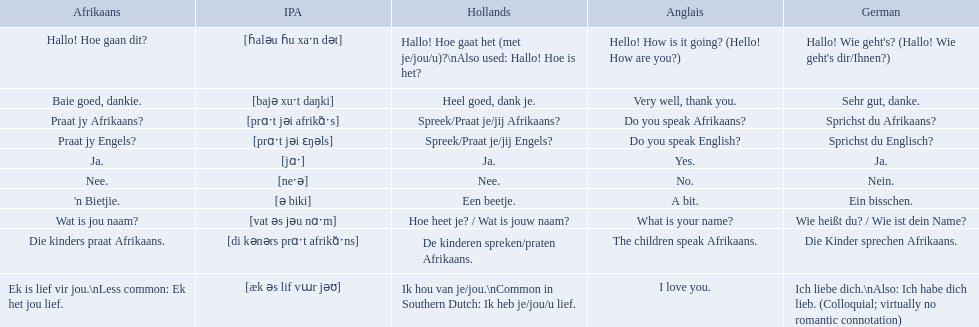Can you give me this table in json format? {'header': ['Afrikaans', 'IPA', 'Hollands', 'Anglais', 'German'], 'rows': [['Hallo! Hoe gaan dit?', '[ɦaləu ɦu xaˑn dət]', 'Hallo! Hoe gaat het (met je/jou/u)?\\nAlso used: Hallo! Hoe is het?', 'Hello! How is it going? (Hello! How are you?)', "Hallo! Wie geht's? (Hallo! Wie geht's dir/Ihnen?)"], ['Baie goed, dankie.', '[bajə xuˑt daŋki]', 'Heel goed, dank je.', 'Very well, thank you.', 'Sehr gut, danke.'], ['Praat jy Afrikaans?', '[prɑˑt jəi afrikɑ̃ˑs]', 'Spreek/Praat je/jij Afrikaans?', 'Do you speak Afrikaans?', 'Sprichst du Afrikaans?'], ['Praat jy Engels?', '[prɑˑt jəi ɛŋəls]', 'Spreek/Praat je/jij Engels?', 'Do you speak English?', 'Sprichst du Englisch?'], ['Ja.', '[jɑˑ]', 'Ja.', 'Yes.', 'Ja.'], ['Nee.', '[neˑə]', 'Nee.', 'No.', 'Nein.'], ["'n Bietjie.", '[ə biki]', 'Een beetje.', 'A bit.', 'Ein bisschen.'], ['Wat is jou naam?', '[vat əs jəu nɑˑm]', 'Hoe heet je? / Wat is jouw naam?', 'What is your name?', 'Wie heißt du? / Wie ist dein Name?'], ['Die kinders praat Afrikaans.', '[di kənərs prɑˑt afrikɑ̃ˑns]', 'De kinderen spreken/praten Afrikaans.', 'The children speak Afrikaans.', 'Die Kinder sprechen Afrikaans.'], ['Ek is lief vir jou.\\nLess common: Ek het jou lief.', '[æk əs lif vɯr jəʊ]', 'Ik hou van je/jou.\\nCommon in Southern Dutch: Ik heb je/jou/u lief.', 'I love you.', 'Ich liebe dich.\\nAlso: Ich habe dich lieb. (Colloquial; virtually no romantic connotation)']]} How do you say do you speak english in german? Sprichst du Englisch?. What about do you speak afrikaanss? in afrikaans? Praat jy Afrikaans?. What are all of the afrikaans phrases shown in the table? Hallo! Hoe gaan dit?, Baie goed, dankie., Praat jy Afrikaans?, Praat jy Engels?, Ja., Nee., 'n Bietjie., Wat is jou naam?, Die kinders praat Afrikaans., Ek is lief vir jou.\nLess common: Ek het jou lief. Of those, which translates into english as do you speak afrikaans?? Praat jy Afrikaans?. 